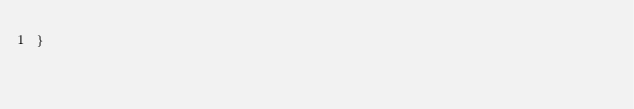<code> <loc_0><loc_0><loc_500><loc_500><_CSS_>}
</code> 